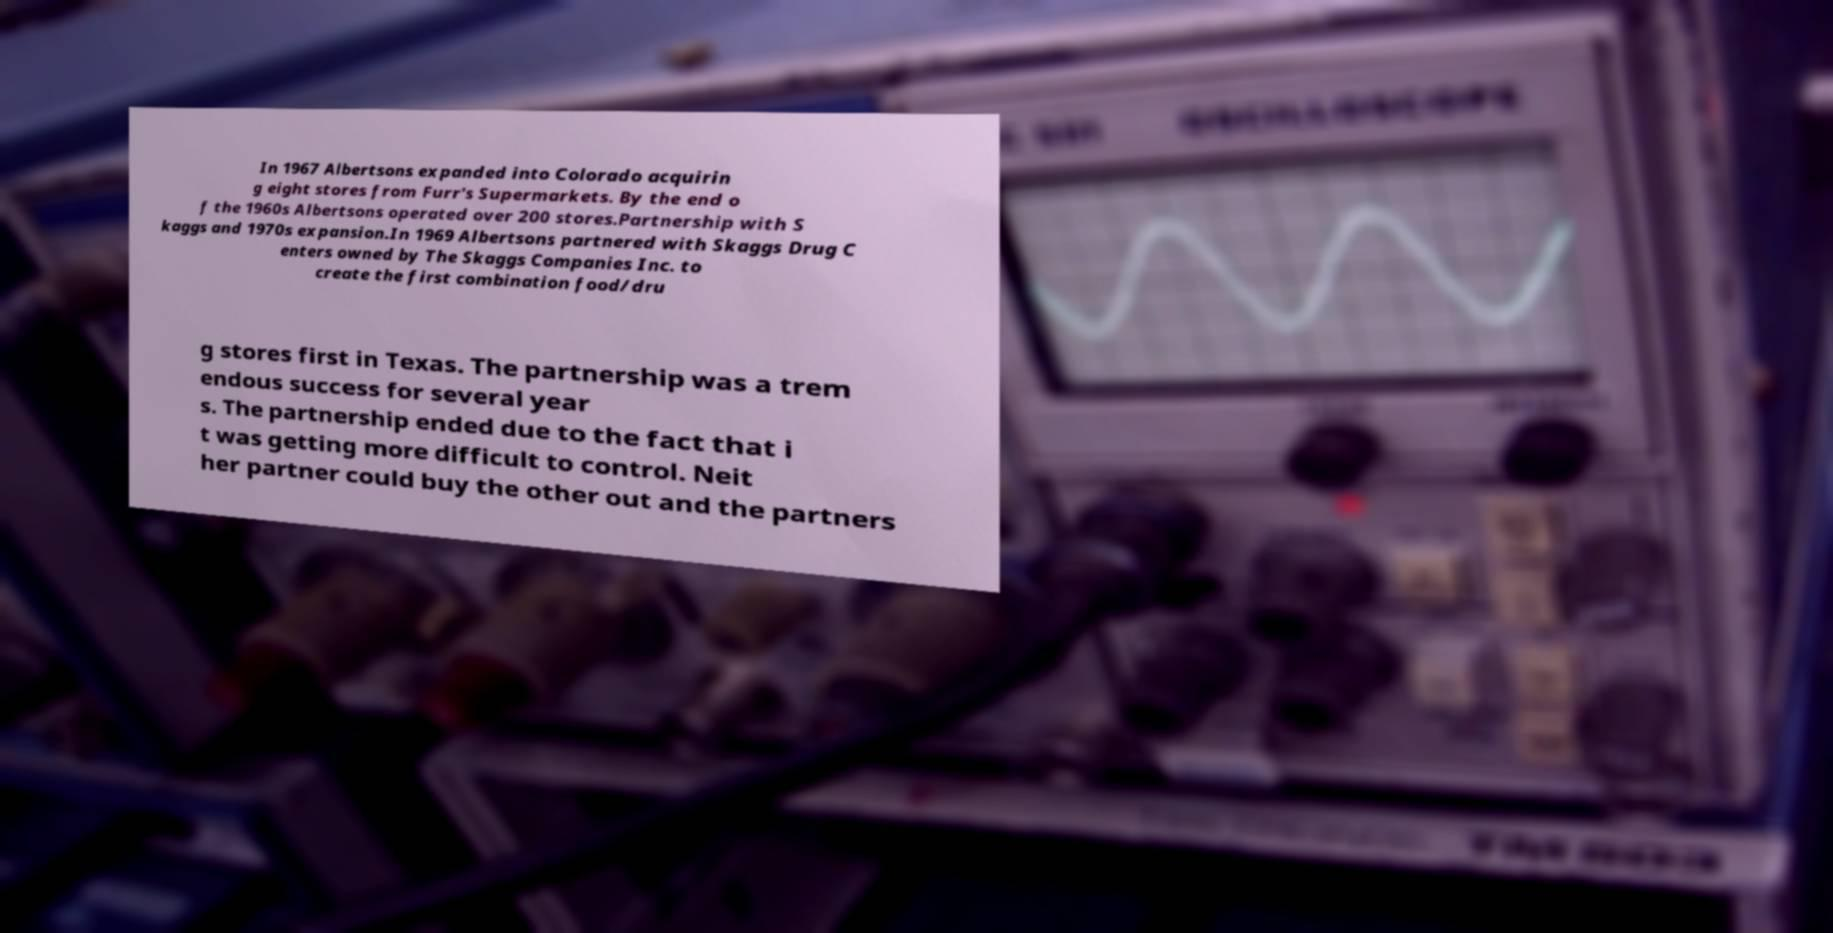What messages or text are displayed in this image? I need them in a readable, typed format. In 1967 Albertsons expanded into Colorado acquirin g eight stores from Furr's Supermarkets. By the end o f the 1960s Albertsons operated over 200 stores.Partnership with S kaggs and 1970s expansion.In 1969 Albertsons partnered with Skaggs Drug C enters owned by The Skaggs Companies Inc. to create the first combination food/dru g stores first in Texas. The partnership was a trem endous success for several year s. The partnership ended due to the fact that i t was getting more difficult to control. Neit her partner could buy the other out and the partners 